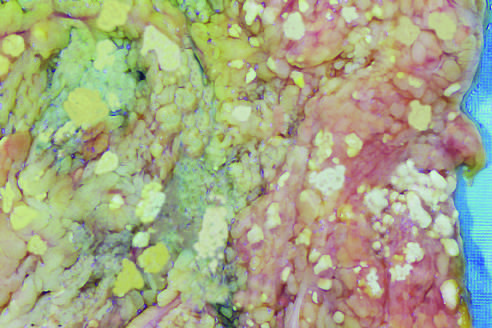do the areas of white chalky deposits represent foci of fat necrosis with calcium soap formation at sites of lipid breakdown in the mesentery?
Answer the question using a single word or phrase. Yes 